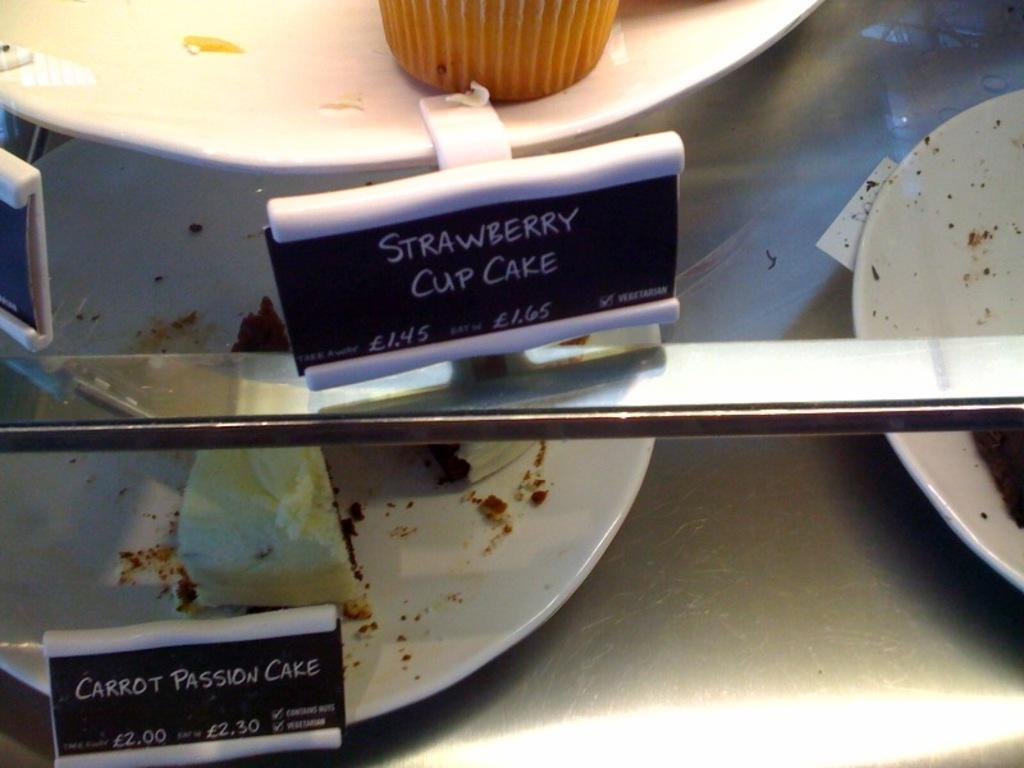What objects are present in the image? There are boards, a plate with a muffin, and plates with cakes under a glass platform. What is the glass platform resting on? The glass platform is resting on a glass platform. Are there any boards on the glass platform? Yes, there is a board on the glass platform. What type of advertisement can be seen on the board in the image? There is no advertisement present on the board in the image. How many tubs are visible in the image? There are no tubs visible in the image. 